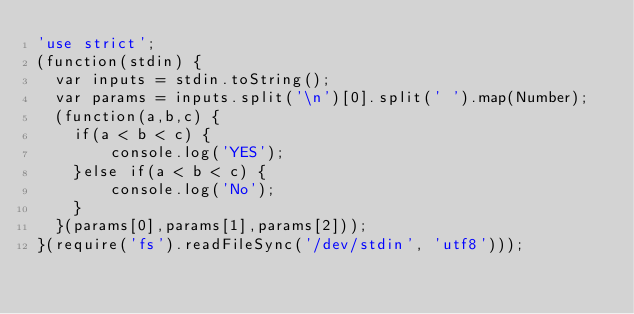<code> <loc_0><loc_0><loc_500><loc_500><_JavaScript_>'use strict';
(function(stdin) { 
  var inputs = stdin.toString();
  var params = inputs.split('\n')[0].split(' ').map(Number);
  (function(a,b,c) {
    if(a < b < c) {
        console.log('YES');
    }else if(a < b < c) {
        console.log('No');
    }
  }(params[0],params[1],params[2])); 
}(require('fs').readFileSync('/dev/stdin', 'utf8')));</code> 